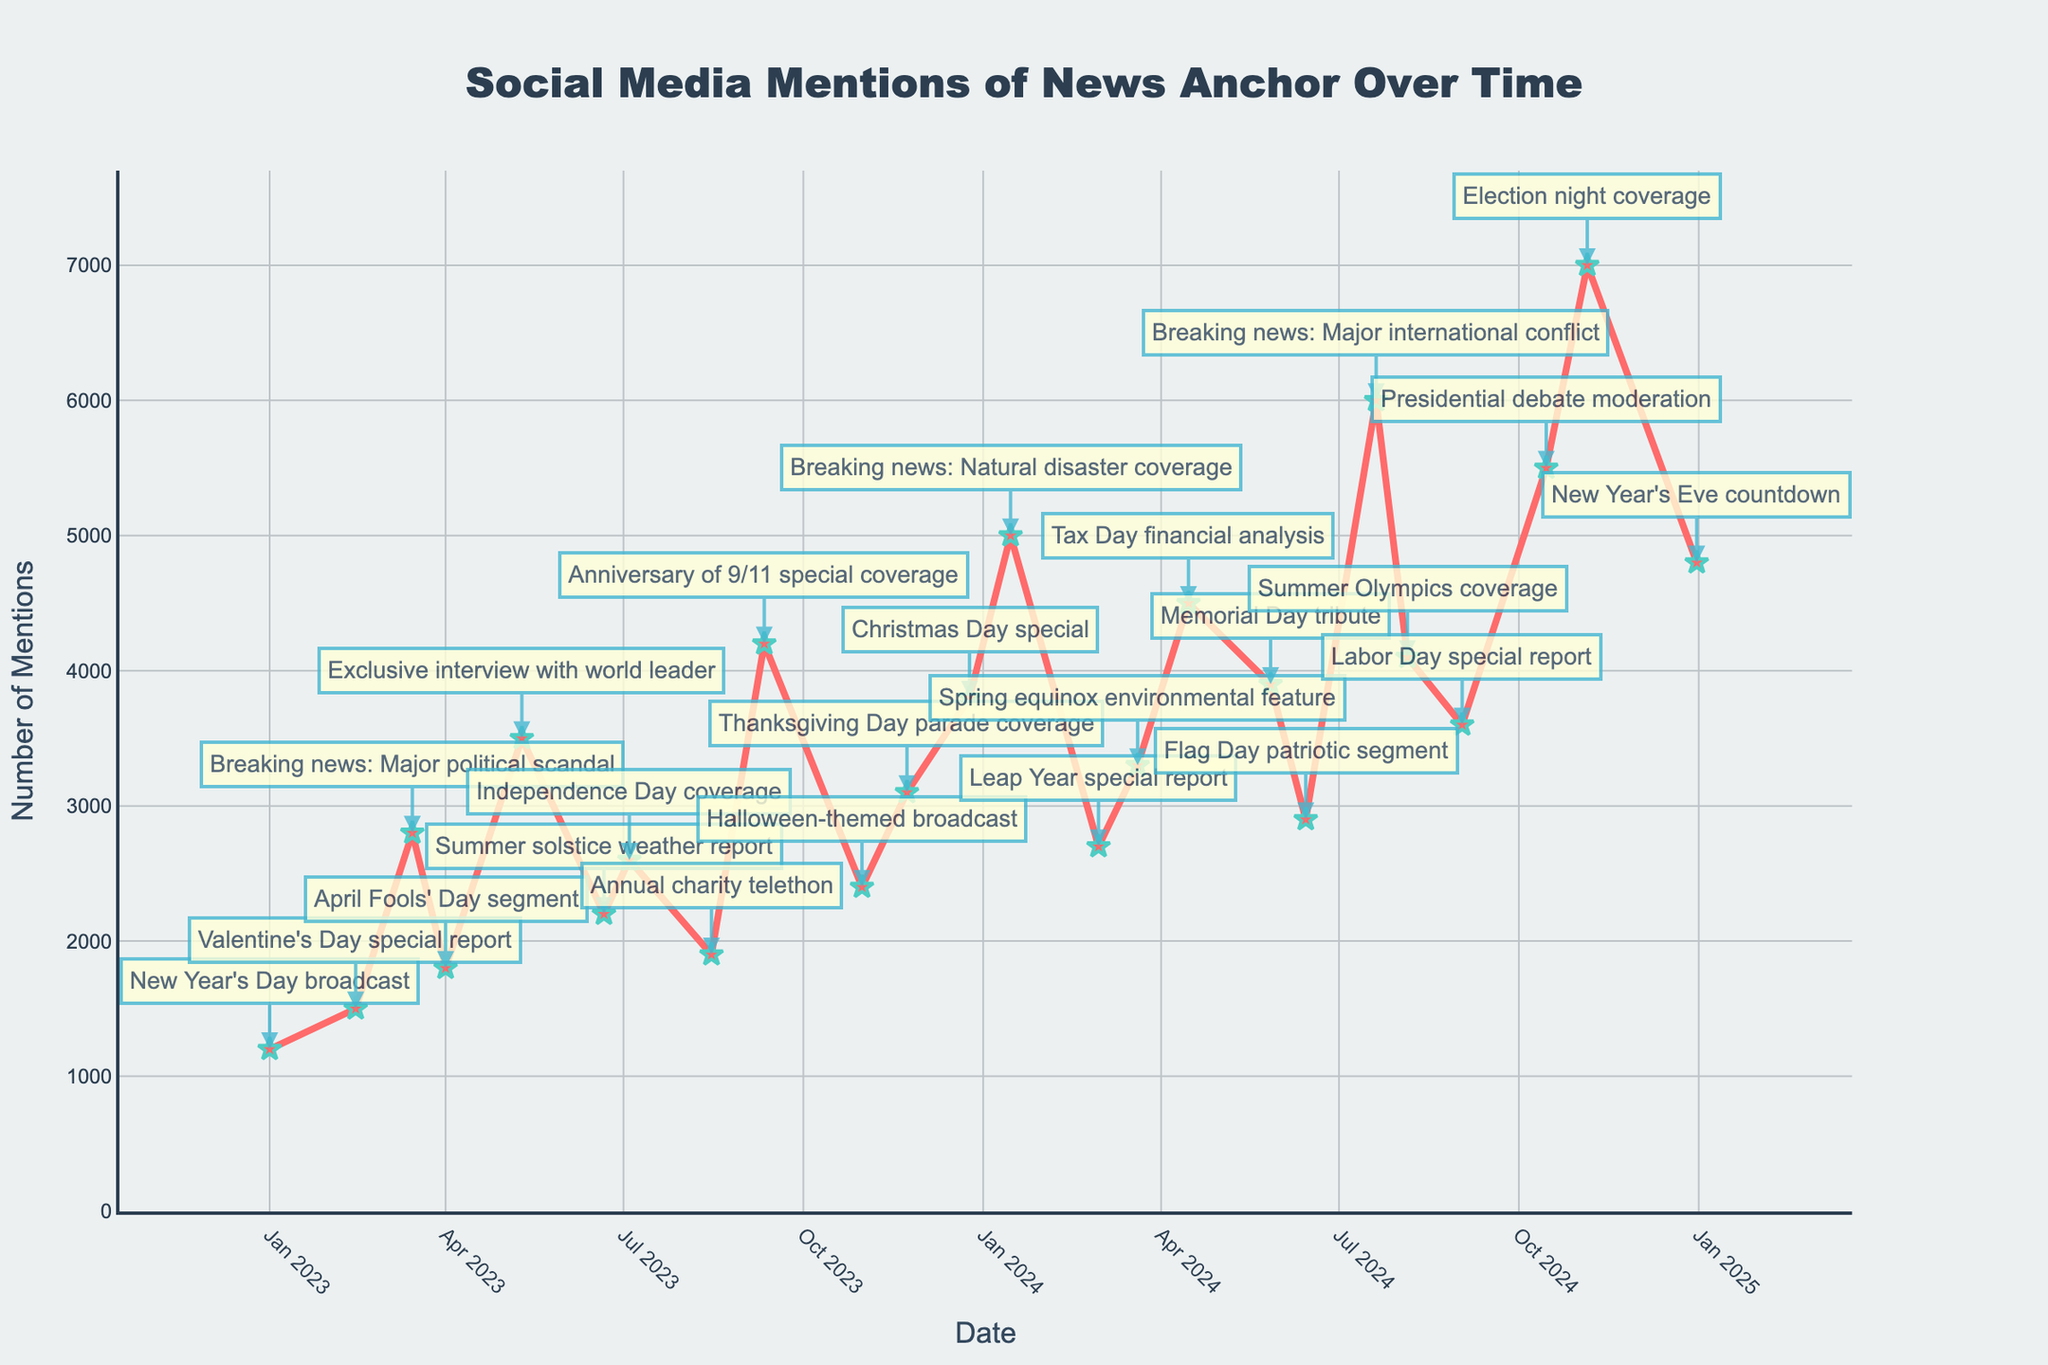What was the date with the highest number of social media mentions? To find this, look at the plot and identify the peak point on the line chart which corresponds to the highest number of mentions. The peak occurs around November 5th, 2024, associated with 'Election night coverage'.
Answer: November 5, 2024 How many more mentions were there on the day of the Tax Day financial analysis compared to Summer solstice weather report? First, find the number of mentions for both dates from the graph. Tax Day financial analysis on April 15, 2024, had around 4500 mentions, and Summer solstice weather report on June 21, 2023, had around 2200 mentions. Subtract the latter from the former: 4500 - 2200 = 2300.
Answer: 2300 What is the average number of mentions for events occurring between June 21, 2023, and July 4, 2024? Identify the events within this period: Summer solstice weather report (2200), Independence Day coverage (2600), Annual charity telethon (1900), Anniversary of 9/11 special coverage (4200), Halloween-themed broadcast (2400), Thanksgiving Day parade coverage (3100), Christmas Day special (3800), and Breaking news: Natural disaster coverage (5000). Sum these values: 2200 + 2600 + 1900 + 4200 + 2400 + 3100 + 3800 + 5000 = 25200. Average is 25200/8 = 3150.
Answer: 3150 Which event caused a spike in mentions immediately following the New Year's Day broadcast in 2023? Inspect the plot for the next notable peak after the New Year's Day broadcast. The next significant spike occurs on Valentine's Day special report on February 14, 2023.
Answer: Valentine's Day special report Between which two consecutive events is the largest increase in mentions observed? Observe the plot for the largest vertical jump between any two consecutive points. The largest increase happens between the Exclusive interview with world leader (3500 mentions) on May 10, 2023, and the Anniversary of 9/11 special coverage (4200 mentions) on September 11, 2023.
Answer: Exclusive interview with world leader to Anniversary of 9/11 special coverage What is the range of social media mentions for the events displayed? Find the minimum and maximum values of the mentions from the visual data. The minimum value is 1200 (New Year's Day broadcast on January 1, 2023), and the maximum value is 7000 (Election night coverage on November 5, 2024). Thus, the range is 7000 - 1200 = 5800.
Answer: 5800 Explain which visual clue helps identify the "Breaking news: Major international conflict" event? Look for visual cues such as annotations and noticeable spikes on the chart. The "Breaking news: Major international conflict" event is marked by a significant peak point, noticeable around July 20, 2024, with an arrow pointing to it and mentioning the event.
Answer: a significant peak and annotation 